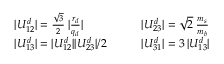Convert formula to latex. <formula><loc_0><loc_0><loc_500><loc_500>\begin{array} { l l l l } { { | U _ { 1 2 } ^ { d } | = \frac { \sqrt { 3 } } 2 \, | \frac { r _ { d } } { q _ { d } } | } } & { { | U _ { 2 3 } ^ { d } | = \sqrt { 2 } \, \frac { m _ { s } } { m _ { b } } } } \\ { { | U _ { 1 3 } ^ { d } | = | U _ { 1 2 } ^ { d } | | U _ { 2 3 } ^ { d } | / 2 } } & { { | U _ { 3 1 } ^ { d } | = 3 \, | U _ { 1 3 } ^ { d } | } } \end{array}</formula> 